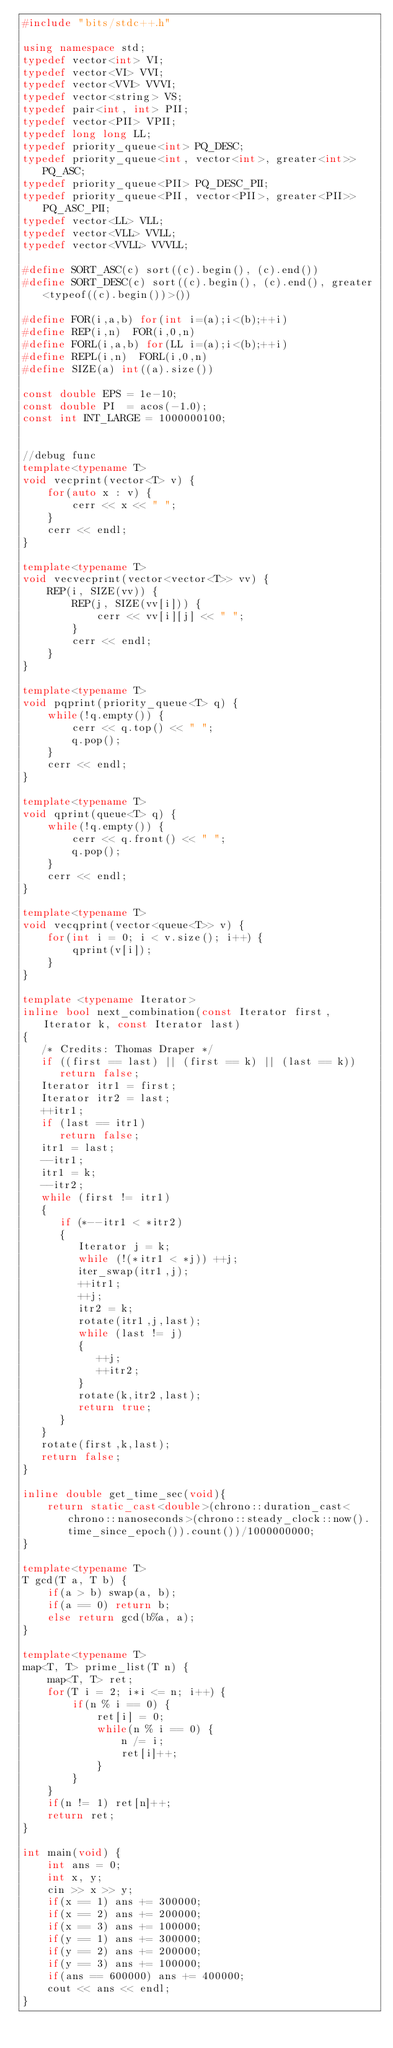Convert code to text. <code><loc_0><loc_0><loc_500><loc_500><_C++_>#include "bits/stdc++.h"
 
using namespace std;
typedef vector<int> VI;
typedef vector<VI> VVI;
typedef vector<VVI> VVVI;
typedef vector<string> VS;
typedef pair<int, int> PII;
typedef vector<PII> VPII;
typedef long long LL;
typedef priority_queue<int> PQ_DESC;
typedef priority_queue<int, vector<int>, greater<int>> PQ_ASC;
typedef priority_queue<PII> PQ_DESC_PII;
typedef priority_queue<PII, vector<PII>, greater<PII>> PQ_ASC_PII;
typedef vector<LL> VLL;
typedef vector<VLL> VVLL;
typedef vector<VVLL> VVVLL;

#define SORT_ASC(c) sort((c).begin(), (c).end())
#define SORT_DESC(c) sort((c).begin(), (c).end(), greater<typeof((c).begin())>())
 
#define FOR(i,a,b) for(int i=(a);i<(b);++i)
#define REP(i,n)  FOR(i,0,n)
#define FORL(i,a,b) for(LL i=(a);i<(b);++i)
#define REPL(i,n)  FORL(i,0,n)
#define SIZE(a) int((a).size())
 
const double EPS = 1e-10;
const double PI  = acos(-1.0);
const int INT_LARGE = 1000000100;
 
 
//debug func
template<typename T>
void vecprint(vector<T> v) {
    for(auto x : v) {
        cerr << x << " ";
    }
    cerr << endl;
}
 
template<typename T>
void vecvecprint(vector<vector<T>> vv) {
    REP(i, SIZE(vv)) {
        REP(j, SIZE(vv[i])) {
            cerr << vv[i][j] << " ";
        }
        cerr << endl;
    }
}
 
template<typename T>
void pqprint(priority_queue<T> q) {
    while(!q.empty()) {
        cerr << q.top() << " ";
        q.pop();
    }
    cerr << endl;
}
 
template<typename T>
void qprint(queue<T> q) {
    while(!q.empty()) {
        cerr << q.front() << " ";
        q.pop();
    }
    cerr << endl;
}
 
template<typename T>
void vecqprint(vector<queue<T>> v) {
    for(int i = 0; i < v.size(); i++) {
        qprint(v[i]);
    }
}
 
template <typename Iterator>
inline bool next_combination(const Iterator first, Iterator k, const Iterator last)
{
   /* Credits: Thomas Draper */
   if ((first == last) || (first == k) || (last == k))
      return false;
   Iterator itr1 = first;
   Iterator itr2 = last;
   ++itr1;
   if (last == itr1)
      return false;
   itr1 = last;
   --itr1;
   itr1 = k;
   --itr2;
   while (first != itr1)
   {
      if (*--itr1 < *itr2)
      {
         Iterator j = k;
         while (!(*itr1 < *j)) ++j;
         iter_swap(itr1,j);
         ++itr1;
         ++j;
         itr2 = k;
         rotate(itr1,j,last);
         while (last != j)
         {
            ++j;
            ++itr2;
         }
         rotate(k,itr2,last);
         return true;
      }
   }
   rotate(first,k,last);
   return false;
}

inline double get_time_sec(void){
    return static_cast<double>(chrono::duration_cast<chrono::nanoseconds>(chrono::steady_clock::now().time_since_epoch()).count())/1000000000;
}

template<typename T>
T gcd(T a, T b) {
    if(a > b) swap(a, b);
    if(a == 0) return b;
    else return gcd(b%a, a);
}

template<typename T>
map<T, T> prime_list(T n) {
    map<T, T> ret;
    for(T i = 2; i*i <= n; i++) {
        if(n % i == 0) {
            ret[i] = 0;
            while(n % i == 0) {
                n /= i;
                ret[i]++;
            }
        } 
    }
    if(n != 1) ret[n]++;
    return ret;
}

int main(void) {
    int ans = 0;
    int x, y;
    cin >> x >> y;
    if(x == 1) ans += 300000;
    if(x == 2) ans += 200000;
    if(x == 3) ans += 100000;
    if(y == 1) ans += 300000;
    if(y == 2) ans += 200000;
    if(y == 3) ans += 100000;
    if(ans == 600000) ans += 400000;
    cout << ans << endl;
}</code> 